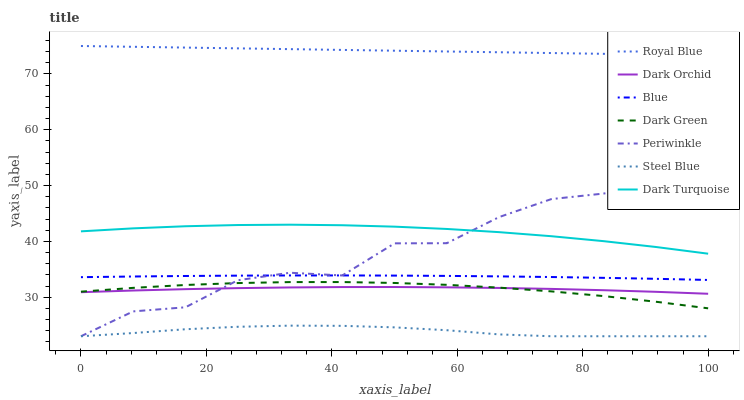Does Steel Blue have the minimum area under the curve?
Answer yes or no. Yes. Does Royal Blue have the maximum area under the curve?
Answer yes or no. Yes. Does Dark Turquoise have the minimum area under the curve?
Answer yes or no. No. Does Dark Turquoise have the maximum area under the curve?
Answer yes or no. No. Is Royal Blue the smoothest?
Answer yes or no. Yes. Is Periwinkle the roughest?
Answer yes or no. Yes. Is Dark Turquoise the smoothest?
Answer yes or no. No. Is Dark Turquoise the roughest?
Answer yes or no. No. Does Dark Turquoise have the lowest value?
Answer yes or no. No. Does Dark Turquoise have the highest value?
Answer yes or no. No. Is Steel Blue less than Dark Orchid?
Answer yes or no. Yes. Is Dark Orchid greater than Steel Blue?
Answer yes or no. Yes. Does Steel Blue intersect Dark Orchid?
Answer yes or no. No. 